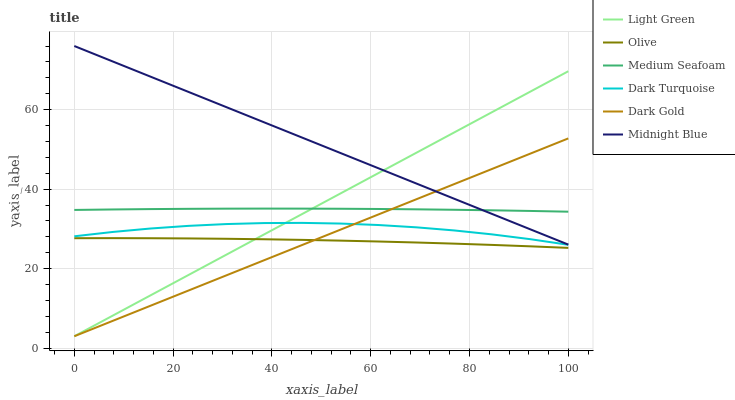Does Olive have the minimum area under the curve?
Answer yes or no. Yes. Does Midnight Blue have the maximum area under the curve?
Answer yes or no. Yes. Does Dark Gold have the minimum area under the curve?
Answer yes or no. No. Does Dark Gold have the maximum area under the curve?
Answer yes or no. No. Is Dark Gold the smoothest?
Answer yes or no. Yes. Is Dark Turquoise the roughest?
Answer yes or no. Yes. Is Dark Turquoise the smoothest?
Answer yes or no. No. Is Dark Gold the roughest?
Answer yes or no. No. Does Dark Gold have the lowest value?
Answer yes or no. Yes. Does Dark Turquoise have the lowest value?
Answer yes or no. No. Does Midnight Blue have the highest value?
Answer yes or no. Yes. Does Dark Gold have the highest value?
Answer yes or no. No. Is Olive less than Midnight Blue?
Answer yes or no. Yes. Is Medium Seafoam greater than Dark Turquoise?
Answer yes or no. Yes. Does Light Green intersect Dark Gold?
Answer yes or no. Yes. Is Light Green less than Dark Gold?
Answer yes or no. No. Is Light Green greater than Dark Gold?
Answer yes or no. No. Does Olive intersect Midnight Blue?
Answer yes or no. No. 